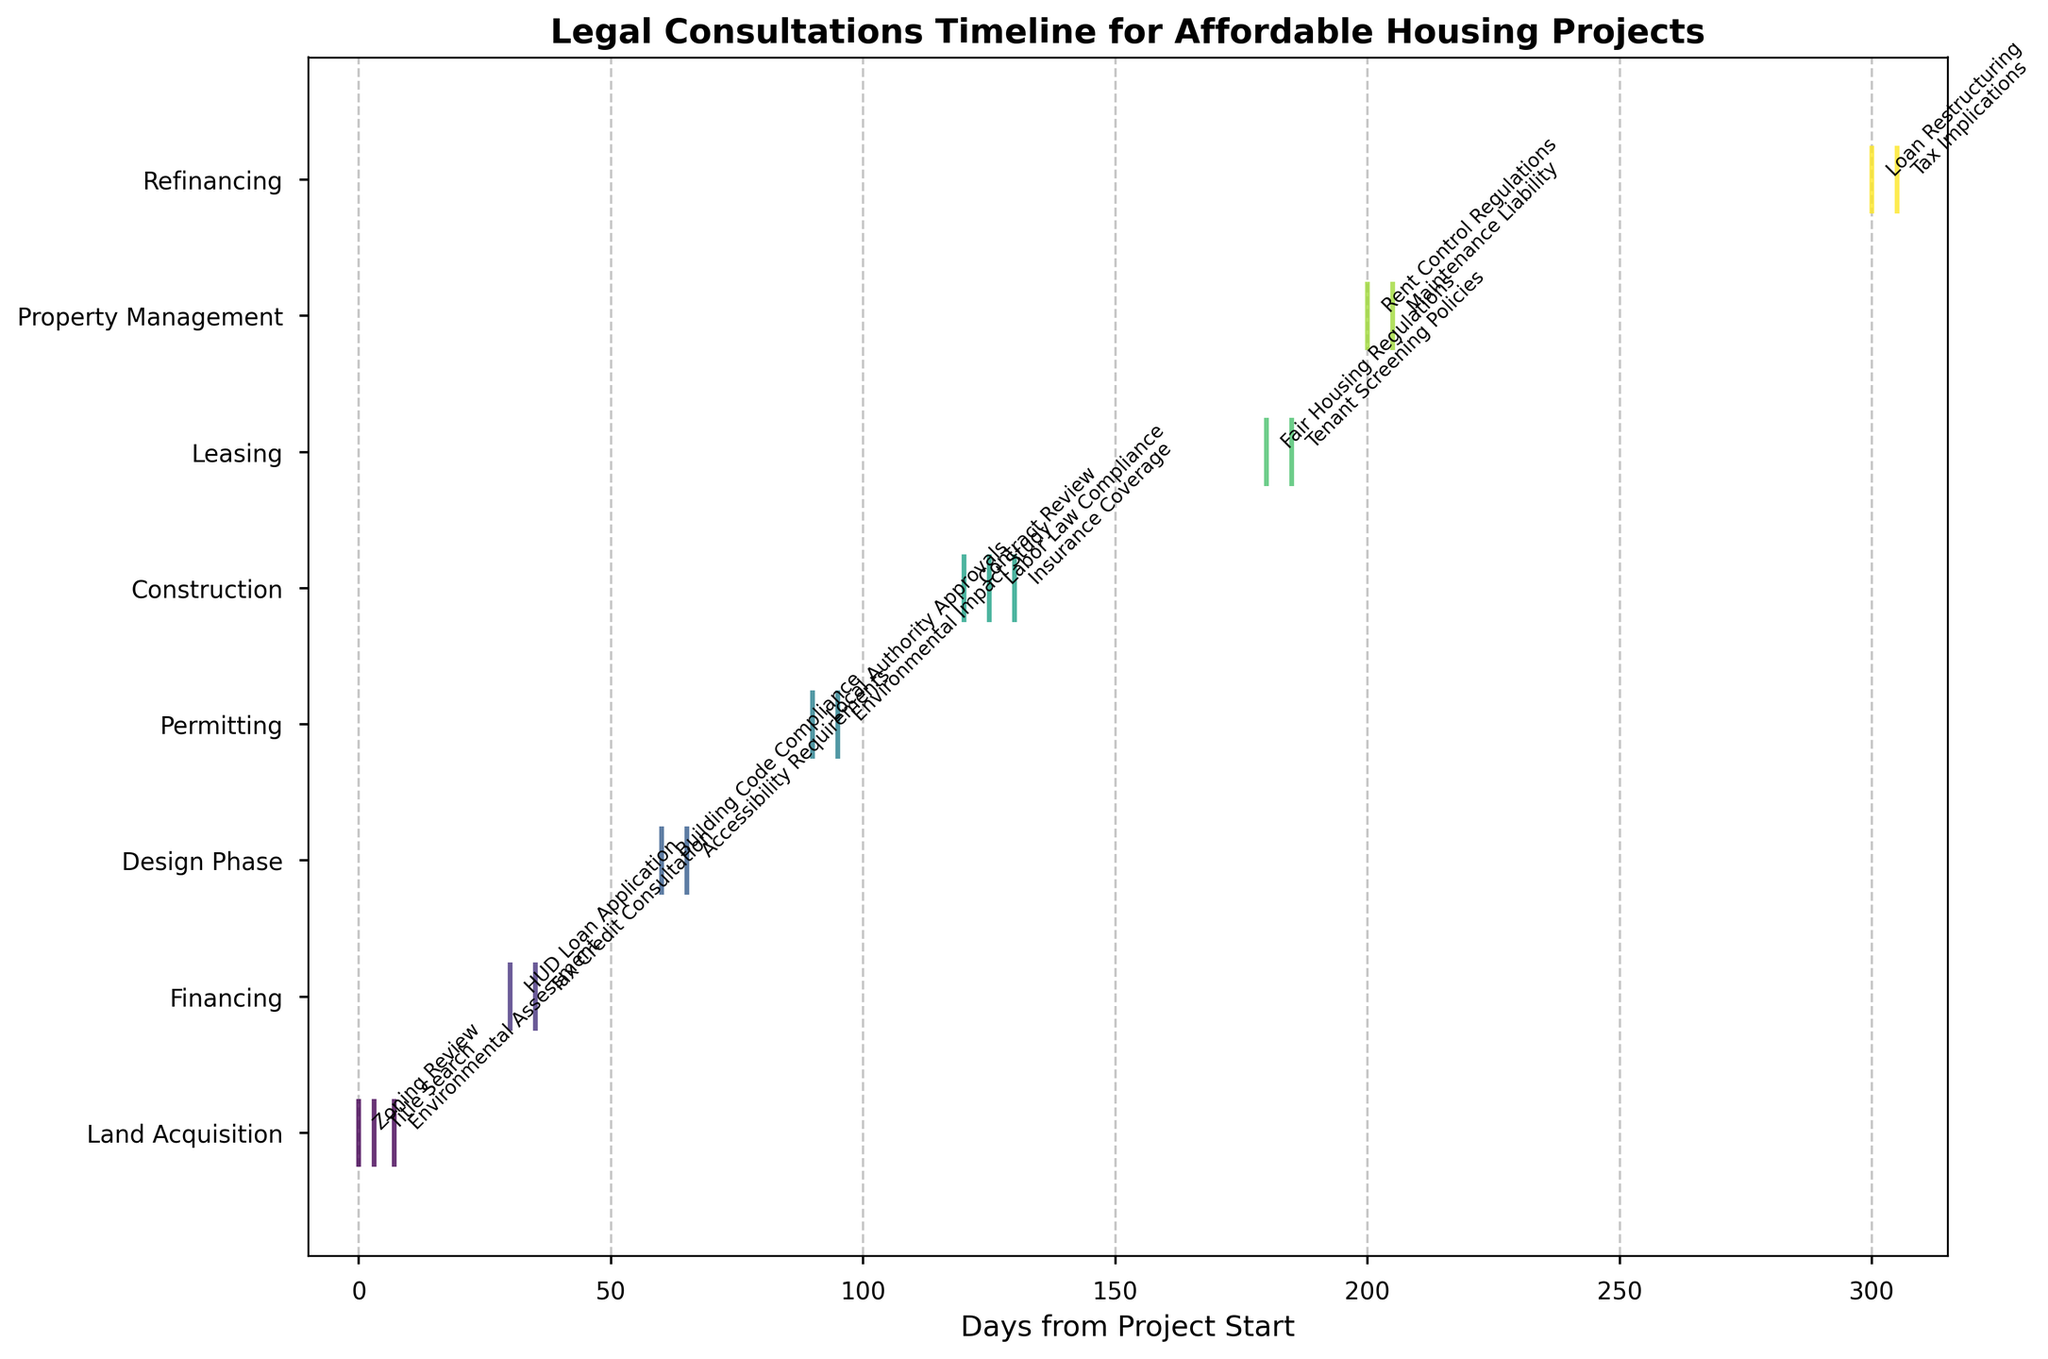What is the title of the figure? The title of the figure can be found at the top and is usually bold and larger in font size compared to other text elements. In this figure, it is clearly stated at the top.
Answer: 'Legal Consultations Timeline for Affordable Housing Projects' How many distinct project stages are there? By looking at the y-axis labels, we can count the number of distinct project stages listed. Each stage corresponds to a line of data points.
Answer: 7 Which project stage has the earliest legal consultation? The earliest legal consultation can be identified by finding the point on the x-axis closest to zero and checking the corresponding y-axis label.
Answer: Land Acquisition How many legal consultations occur during the 'Construction' stage? By finding the 'Construction' stage on the y-axis, we count the number of data points (vertical lines) that align with this stage.
Answer: 3 Which two project stages have consultations closest in time to each other? By examining the distance between consultations on the x-axis within a single stage, we can find the smallest gap. In this case, compare the days between consultations for all stages.
Answer: Leasing and Property Management What is the total duration covered from the first to the last legal consultation? To calculate this, subtract the x-axis value of the earliest consultation from the x-axis value of the latest consultation.
Answer: 305 days What legal consultation occurs at 95 days from the project start? Finding the data point that corresponds to 95 on the x-axis, we then check its label to identify the legal consultation.
Answer: Environmental Impact Study Which stage of the project lifecycle has the longest gap between consultations? By measuring the largest gap between data points on the x-axis for each stage, we can identify the stage with the longest gap.
Answer: Land Acquisition How many legal consultations occur after 180 days from the project start? Count the number of data points that have x-axis values greater than 180.
Answer: 5 Which project stage has the highest number of legal consultations? By comparing the number of data points for each stage on the y-axis, we can identify the stage with the most consultations.
Answer: Construction 